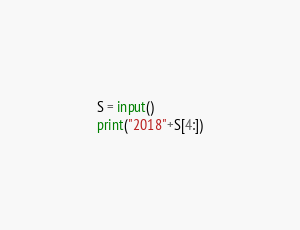Convert code to text. <code><loc_0><loc_0><loc_500><loc_500><_Python_>S = input()
print("2018"+S[4:])</code> 